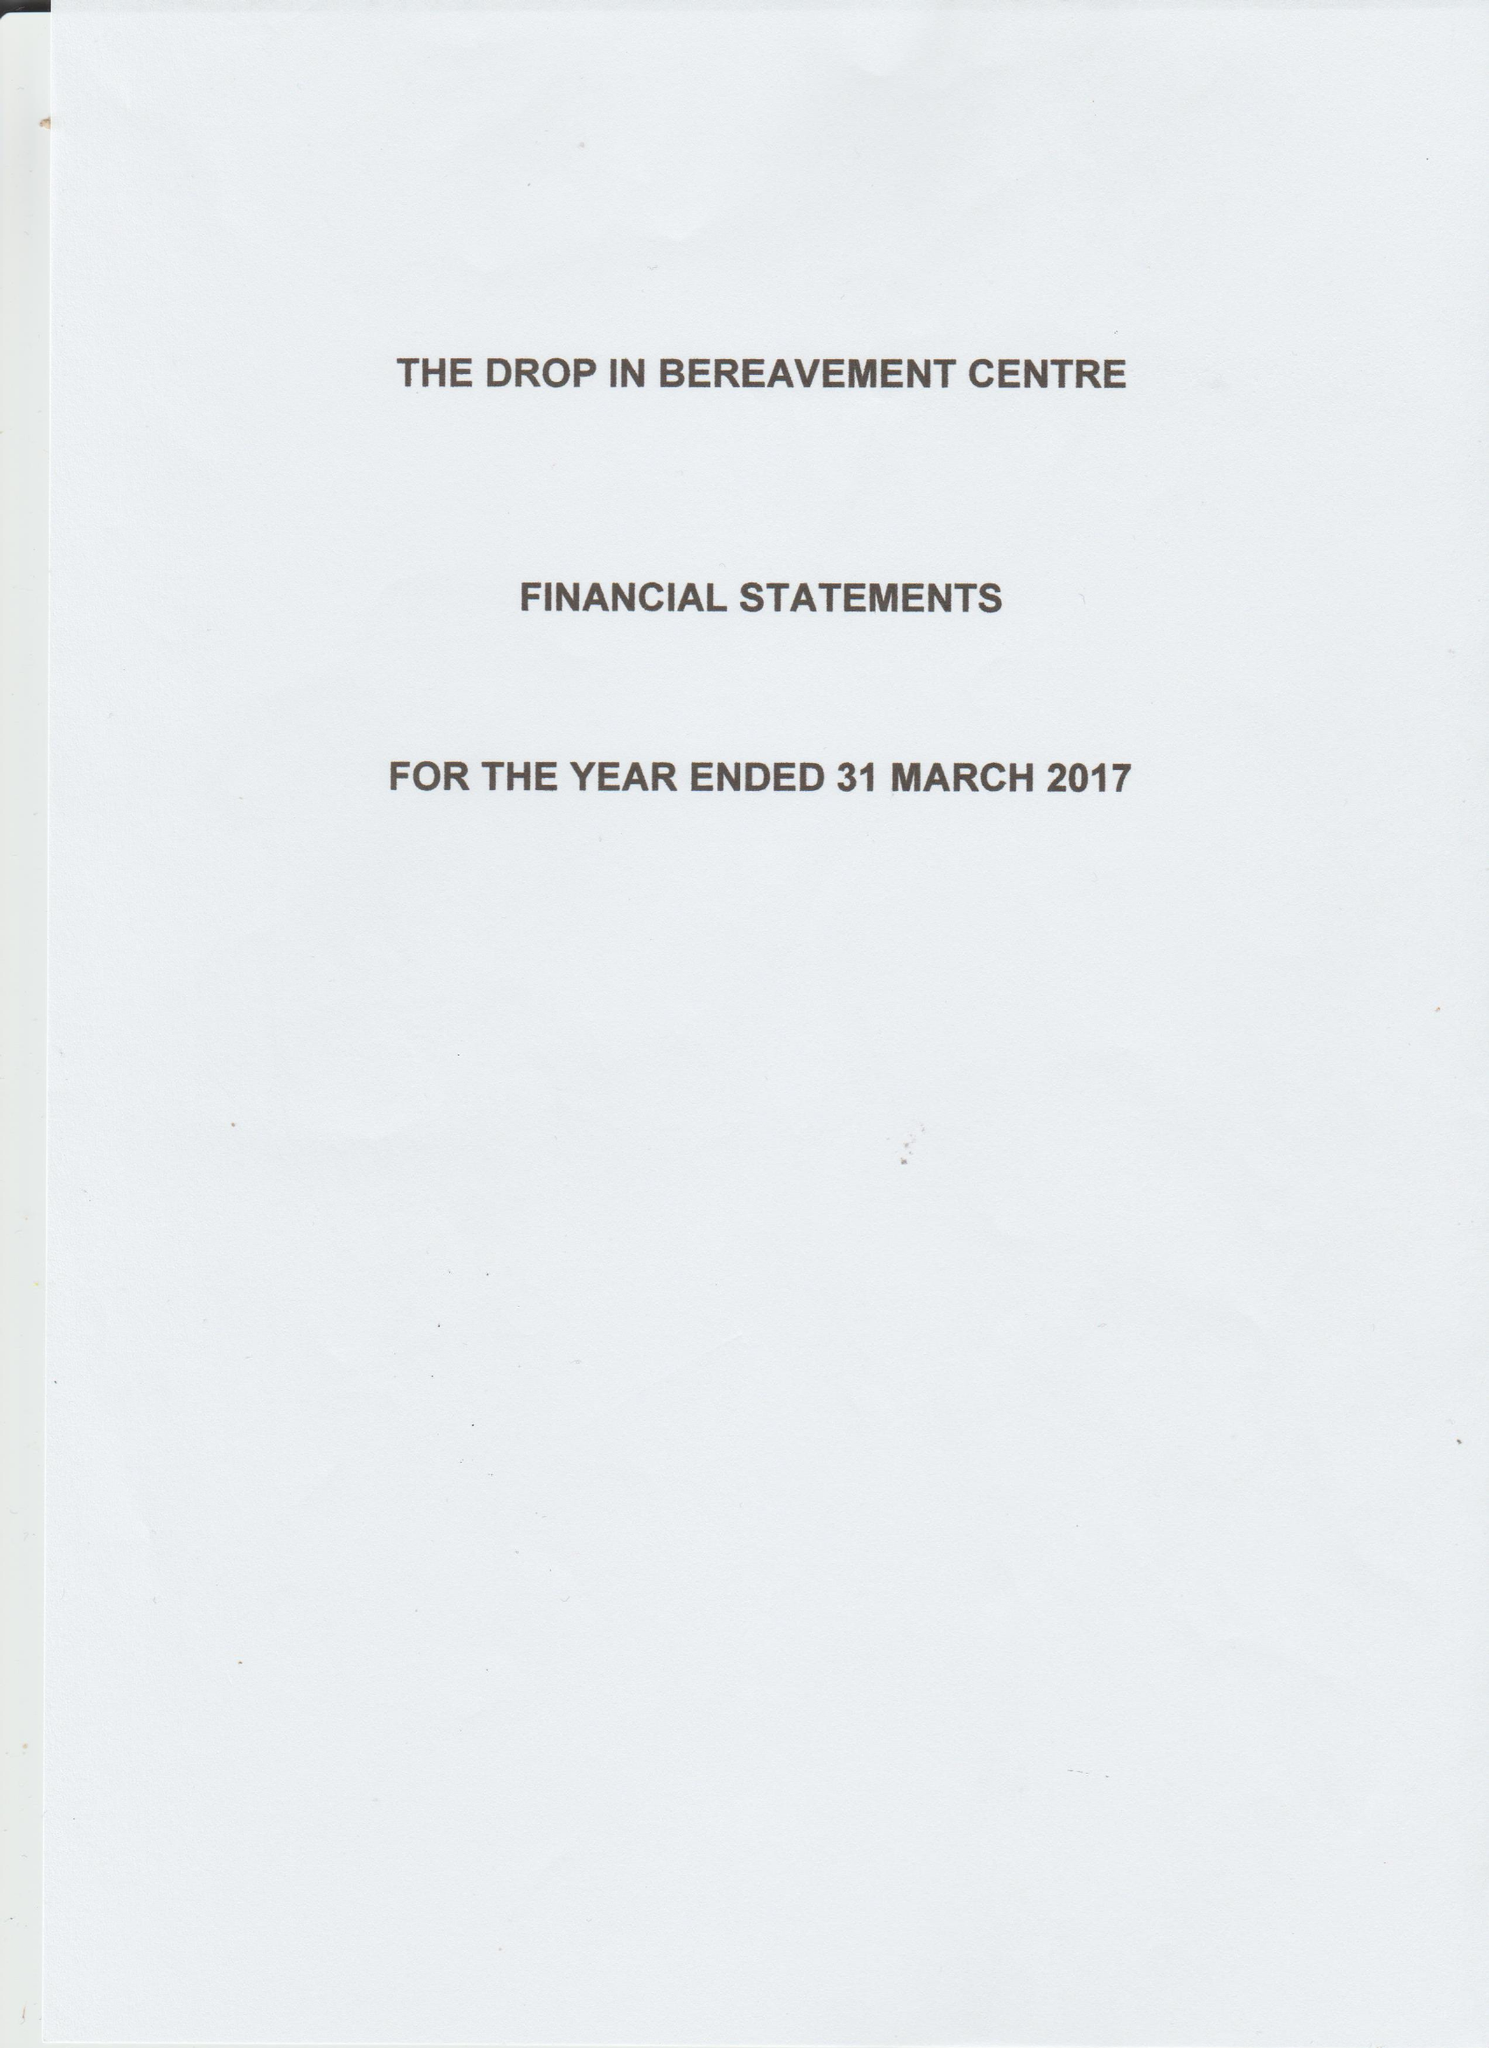What is the value for the charity_name?
Answer the question using a single word or phrase. The Drop In Bereavement Centre 